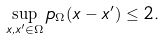Convert formula to latex. <formula><loc_0><loc_0><loc_500><loc_500>\sup _ { x , x ^ { \prime } \in \Omega } p _ { \Omega } ( x - x ^ { \prime } ) \leq 2 .</formula> 